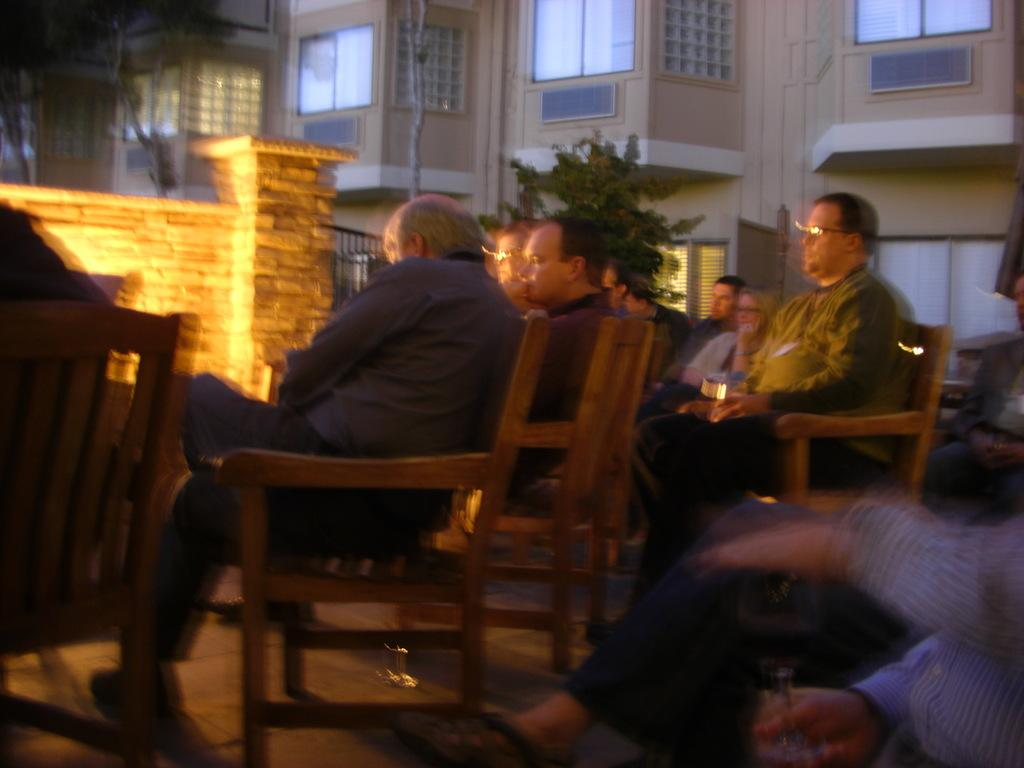What is happening in the image? There is a group of people in the image. What are the people doing in the image? The people are sitting on chairs. What can be seen in the background of the image? There is a building in the background of the image. What type of chess pieces can be seen on the table in the image? There is no table or chess pieces present in the image. Can you provide an example of a similar situation to the one depicted in the image? It is not possible to provide an example of a similar situation based on the information given in the image. 